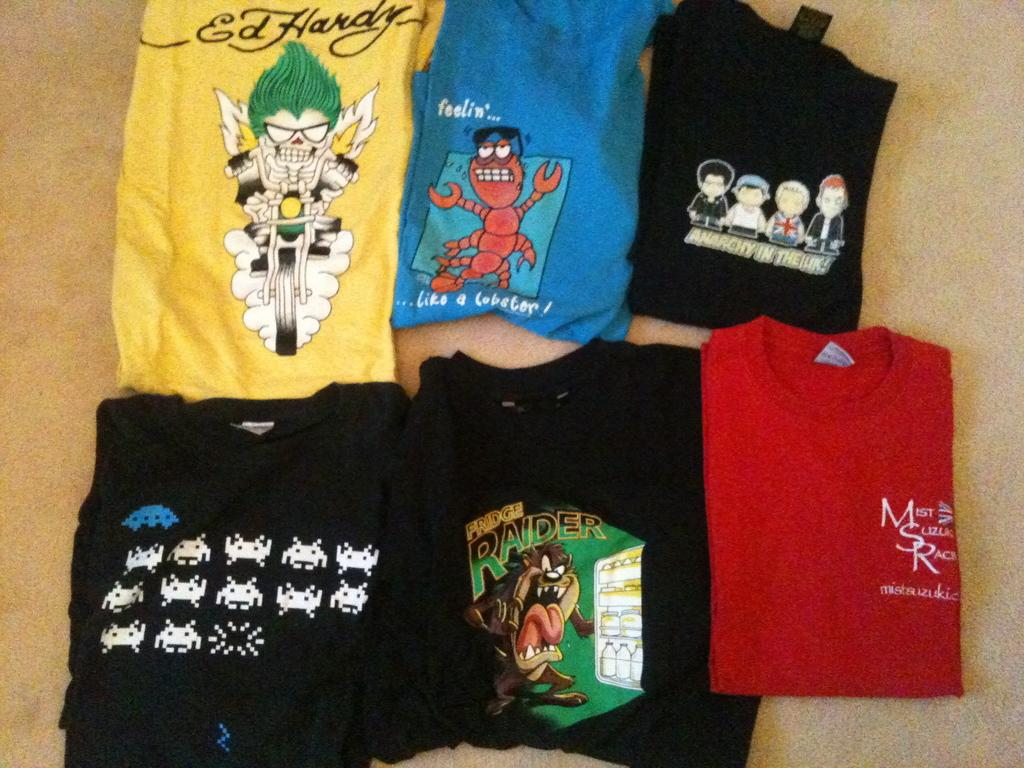What type of clothing is present in the image? The image contains t-shirts. Can you describe the variety of t-shirts in the image? The t-shirts have different colors. What else can be seen on the t-shirts? There are images on the t-shirts. What degree does the owner of the t-shirts have in the image? There is no information about the owner of the t-shirts in the image, nor is there any indication of a degree. How many cherries are visible on the t-shirts in the image? There is no mention of cherries in the image; the t-shirts have different images, but none are specifically described as cherries. 